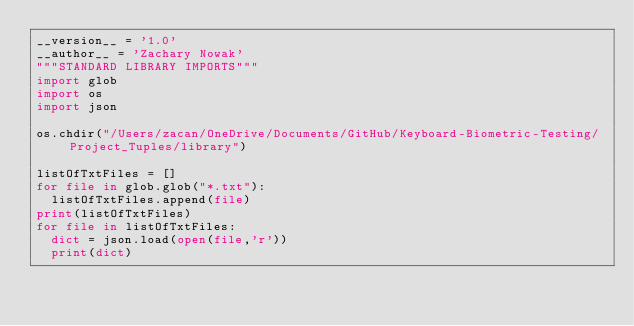Convert code to text. <code><loc_0><loc_0><loc_500><loc_500><_Python_>__version__ = '1.0'
__author__ = 'Zachary Nowak'
"""STANDARD LIBRARY IMPORTS"""
import glob
import os
import json

os.chdir("/Users/zacan/OneDrive/Documents/GitHub/Keyboard-Biometric-Testing/Project_Tuples/library")

listOfTxtFiles = []
for file in glob.glob("*.txt"):
	listOfTxtFiles.append(file)
print(listOfTxtFiles)
for file in listOfTxtFiles:
	dict = json.load(open(file,'r'))
	print(dict)</code> 